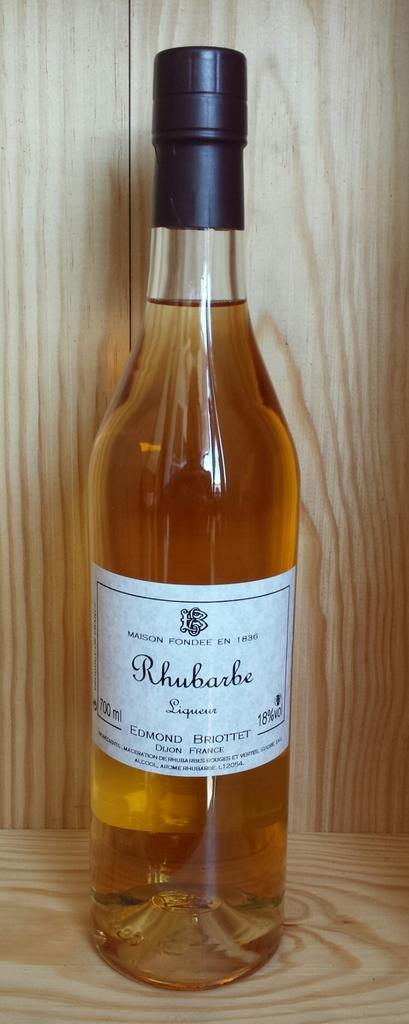<image>
Create a compact narrative representing the image presented. a bottle of maison fondee en 1836 rhubarbe 